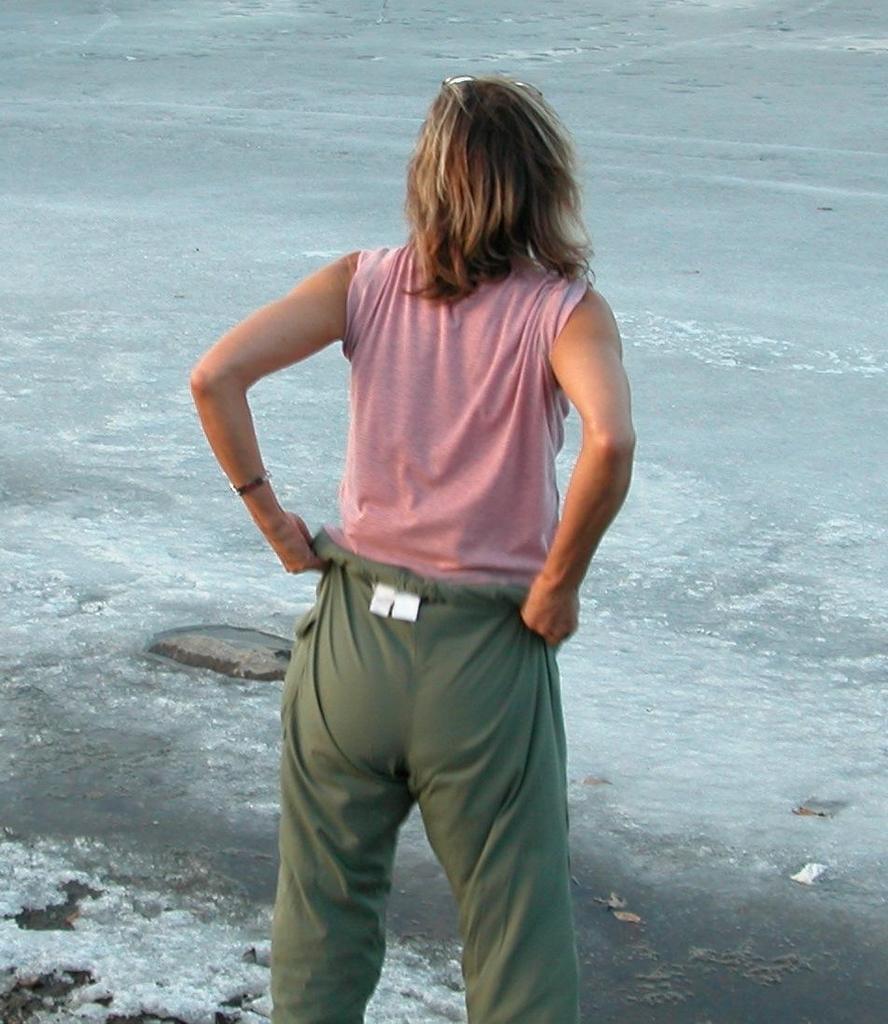Could you give a brief overview of what you see in this image? There is person standing and we can see water. 